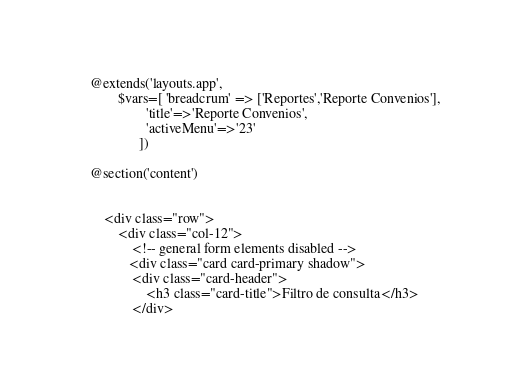Convert code to text. <code><loc_0><loc_0><loc_500><loc_500><_PHP_>@extends('layouts.app',
        $vars=[ 'breadcrum' => ['Reportes','Reporte Convenios'],
                'title'=>'Reporte Convenios',
                'activeMenu'=>'23'
              ])

@section('content')


    <div class="row">
        <div class="col-12">
            <!-- general form elements disabled -->
           <div class="card card-primary shadow">
            <div class="card-header">
                <h3 class="card-title">Filtro de consulta</h3>
            </div></code> 